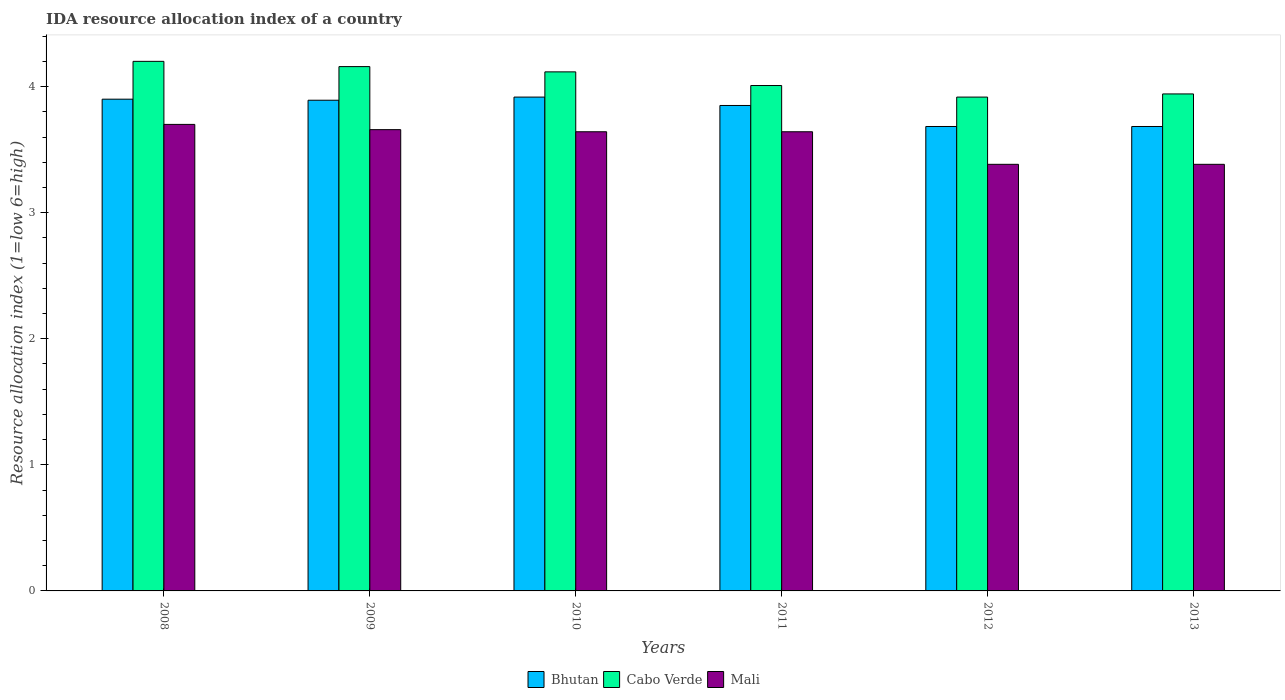How many different coloured bars are there?
Ensure brevity in your answer.  3. Are the number of bars per tick equal to the number of legend labels?
Offer a very short reply. Yes. Are the number of bars on each tick of the X-axis equal?
Your answer should be compact. Yes. How many bars are there on the 3rd tick from the left?
Provide a succinct answer. 3. How many bars are there on the 4th tick from the right?
Your answer should be very brief. 3. What is the label of the 3rd group of bars from the left?
Your response must be concise. 2010. In how many cases, is the number of bars for a given year not equal to the number of legend labels?
Your answer should be compact. 0. What is the IDA resource allocation index in Mali in 2013?
Provide a short and direct response. 3.38. Across all years, what is the minimum IDA resource allocation index in Bhutan?
Your answer should be compact. 3.68. In which year was the IDA resource allocation index in Bhutan maximum?
Your response must be concise. 2010. In which year was the IDA resource allocation index in Cabo Verde minimum?
Make the answer very short. 2012. What is the total IDA resource allocation index in Bhutan in the graph?
Ensure brevity in your answer.  22.92. What is the difference between the IDA resource allocation index in Cabo Verde in 2009 and that in 2010?
Ensure brevity in your answer.  0.04. What is the difference between the IDA resource allocation index in Cabo Verde in 2010 and the IDA resource allocation index in Mali in 2009?
Your answer should be very brief. 0.46. What is the average IDA resource allocation index in Mali per year?
Your answer should be compact. 3.57. In the year 2012, what is the difference between the IDA resource allocation index in Mali and IDA resource allocation index in Cabo Verde?
Provide a succinct answer. -0.53. In how many years, is the IDA resource allocation index in Bhutan greater than 1.4?
Offer a terse response. 6. What is the ratio of the IDA resource allocation index in Mali in 2008 to that in 2011?
Keep it short and to the point. 1.02. Is the IDA resource allocation index in Cabo Verde in 2011 less than that in 2013?
Make the answer very short. No. Is the difference between the IDA resource allocation index in Mali in 2009 and 2010 greater than the difference between the IDA resource allocation index in Cabo Verde in 2009 and 2010?
Give a very brief answer. No. What is the difference between the highest and the second highest IDA resource allocation index in Mali?
Offer a terse response. 0.04. What is the difference between the highest and the lowest IDA resource allocation index in Mali?
Offer a terse response. 0.32. In how many years, is the IDA resource allocation index in Bhutan greater than the average IDA resource allocation index in Bhutan taken over all years?
Keep it short and to the point. 4. What does the 1st bar from the left in 2011 represents?
Provide a short and direct response. Bhutan. What does the 1st bar from the right in 2009 represents?
Make the answer very short. Mali. How many bars are there?
Your answer should be compact. 18. How many years are there in the graph?
Your answer should be very brief. 6. What is the difference between two consecutive major ticks on the Y-axis?
Your answer should be very brief. 1. Are the values on the major ticks of Y-axis written in scientific E-notation?
Your answer should be very brief. No. Does the graph contain grids?
Give a very brief answer. No. Where does the legend appear in the graph?
Provide a succinct answer. Bottom center. How are the legend labels stacked?
Offer a very short reply. Horizontal. What is the title of the graph?
Your response must be concise. IDA resource allocation index of a country. What is the label or title of the X-axis?
Ensure brevity in your answer.  Years. What is the label or title of the Y-axis?
Your response must be concise. Resource allocation index (1=low 6=high). What is the Resource allocation index (1=low 6=high) of Bhutan in 2009?
Offer a terse response. 3.89. What is the Resource allocation index (1=low 6=high) of Cabo Verde in 2009?
Offer a terse response. 4.16. What is the Resource allocation index (1=low 6=high) in Mali in 2009?
Provide a succinct answer. 3.66. What is the Resource allocation index (1=low 6=high) in Bhutan in 2010?
Offer a very short reply. 3.92. What is the Resource allocation index (1=low 6=high) of Cabo Verde in 2010?
Give a very brief answer. 4.12. What is the Resource allocation index (1=low 6=high) in Mali in 2010?
Offer a very short reply. 3.64. What is the Resource allocation index (1=low 6=high) in Bhutan in 2011?
Your response must be concise. 3.85. What is the Resource allocation index (1=low 6=high) of Cabo Verde in 2011?
Make the answer very short. 4.01. What is the Resource allocation index (1=low 6=high) of Mali in 2011?
Your response must be concise. 3.64. What is the Resource allocation index (1=low 6=high) in Bhutan in 2012?
Offer a terse response. 3.68. What is the Resource allocation index (1=low 6=high) of Cabo Verde in 2012?
Give a very brief answer. 3.92. What is the Resource allocation index (1=low 6=high) of Mali in 2012?
Your answer should be very brief. 3.38. What is the Resource allocation index (1=low 6=high) of Bhutan in 2013?
Your response must be concise. 3.68. What is the Resource allocation index (1=low 6=high) of Cabo Verde in 2013?
Keep it short and to the point. 3.94. What is the Resource allocation index (1=low 6=high) of Mali in 2013?
Provide a short and direct response. 3.38. Across all years, what is the maximum Resource allocation index (1=low 6=high) in Bhutan?
Offer a terse response. 3.92. Across all years, what is the maximum Resource allocation index (1=low 6=high) in Mali?
Provide a succinct answer. 3.7. Across all years, what is the minimum Resource allocation index (1=low 6=high) in Bhutan?
Offer a terse response. 3.68. Across all years, what is the minimum Resource allocation index (1=low 6=high) of Cabo Verde?
Offer a terse response. 3.92. Across all years, what is the minimum Resource allocation index (1=low 6=high) in Mali?
Your answer should be very brief. 3.38. What is the total Resource allocation index (1=low 6=high) of Bhutan in the graph?
Keep it short and to the point. 22.93. What is the total Resource allocation index (1=low 6=high) in Cabo Verde in the graph?
Ensure brevity in your answer.  24.34. What is the total Resource allocation index (1=low 6=high) of Mali in the graph?
Your answer should be very brief. 21.41. What is the difference between the Resource allocation index (1=low 6=high) of Bhutan in 2008 and that in 2009?
Give a very brief answer. 0.01. What is the difference between the Resource allocation index (1=low 6=high) in Cabo Verde in 2008 and that in 2009?
Your answer should be very brief. 0.04. What is the difference between the Resource allocation index (1=low 6=high) in Mali in 2008 and that in 2009?
Provide a short and direct response. 0.04. What is the difference between the Resource allocation index (1=low 6=high) of Bhutan in 2008 and that in 2010?
Make the answer very short. -0.02. What is the difference between the Resource allocation index (1=low 6=high) of Cabo Verde in 2008 and that in 2010?
Provide a succinct answer. 0.08. What is the difference between the Resource allocation index (1=low 6=high) in Mali in 2008 and that in 2010?
Your response must be concise. 0.06. What is the difference between the Resource allocation index (1=low 6=high) in Cabo Verde in 2008 and that in 2011?
Give a very brief answer. 0.19. What is the difference between the Resource allocation index (1=low 6=high) of Mali in 2008 and that in 2011?
Provide a short and direct response. 0.06. What is the difference between the Resource allocation index (1=low 6=high) in Bhutan in 2008 and that in 2012?
Keep it short and to the point. 0.22. What is the difference between the Resource allocation index (1=low 6=high) in Cabo Verde in 2008 and that in 2012?
Offer a terse response. 0.28. What is the difference between the Resource allocation index (1=low 6=high) of Mali in 2008 and that in 2012?
Your answer should be very brief. 0.32. What is the difference between the Resource allocation index (1=low 6=high) in Bhutan in 2008 and that in 2013?
Provide a short and direct response. 0.22. What is the difference between the Resource allocation index (1=low 6=high) in Cabo Verde in 2008 and that in 2013?
Make the answer very short. 0.26. What is the difference between the Resource allocation index (1=low 6=high) in Mali in 2008 and that in 2013?
Provide a succinct answer. 0.32. What is the difference between the Resource allocation index (1=low 6=high) of Bhutan in 2009 and that in 2010?
Make the answer very short. -0.03. What is the difference between the Resource allocation index (1=low 6=high) in Cabo Verde in 2009 and that in 2010?
Offer a very short reply. 0.04. What is the difference between the Resource allocation index (1=low 6=high) in Mali in 2009 and that in 2010?
Keep it short and to the point. 0.02. What is the difference between the Resource allocation index (1=low 6=high) in Bhutan in 2009 and that in 2011?
Offer a terse response. 0.04. What is the difference between the Resource allocation index (1=low 6=high) in Cabo Verde in 2009 and that in 2011?
Provide a succinct answer. 0.15. What is the difference between the Resource allocation index (1=low 6=high) of Mali in 2009 and that in 2011?
Your answer should be very brief. 0.02. What is the difference between the Resource allocation index (1=low 6=high) in Bhutan in 2009 and that in 2012?
Offer a very short reply. 0.21. What is the difference between the Resource allocation index (1=low 6=high) of Cabo Verde in 2009 and that in 2012?
Provide a succinct answer. 0.24. What is the difference between the Resource allocation index (1=low 6=high) of Mali in 2009 and that in 2012?
Make the answer very short. 0.28. What is the difference between the Resource allocation index (1=low 6=high) of Bhutan in 2009 and that in 2013?
Give a very brief answer. 0.21. What is the difference between the Resource allocation index (1=low 6=high) of Cabo Verde in 2009 and that in 2013?
Provide a succinct answer. 0.22. What is the difference between the Resource allocation index (1=low 6=high) of Mali in 2009 and that in 2013?
Your answer should be compact. 0.28. What is the difference between the Resource allocation index (1=low 6=high) of Bhutan in 2010 and that in 2011?
Keep it short and to the point. 0.07. What is the difference between the Resource allocation index (1=low 6=high) of Cabo Verde in 2010 and that in 2011?
Offer a very short reply. 0.11. What is the difference between the Resource allocation index (1=low 6=high) in Mali in 2010 and that in 2011?
Your answer should be very brief. 0. What is the difference between the Resource allocation index (1=low 6=high) in Bhutan in 2010 and that in 2012?
Your answer should be very brief. 0.23. What is the difference between the Resource allocation index (1=low 6=high) of Cabo Verde in 2010 and that in 2012?
Provide a short and direct response. 0.2. What is the difference between the Resource allocation index (1=low 6=high) of Mali in 2010 and that in 2012?
Provide a short and direct response. 0.26. What is the difference between the Resource allocation index (1=low 6=high) in Bhutan in 2010 and that in 2013?
Offer a terse response. 0.23. What is the difference between the Resource allocation index (1=low 6=high) in Cabo Verde in 2010 and that in 2013?
Offer a terse response. 0.17. What is the difference between the Resource allocation index (1=low 6=high) of Mali in 2010 and that in 2013?
Offer a very short reply. 0.26. What is the difference between the Resource allocation index (1=low 6=high) of Bhutan in 2011 and that in 2012?
Your answer should be very brief. 0.17. What is the difference between the Resource allocation index (1=low 6=high) of Cabo Verde in 2011 and that in 2012?
Provide a short and direct response. 0.09. What is the difference between the Resource allocation index (1=low 6=high) of Mali in 2011 and that in 2012?
Your answer should be very brief. 0.26. What is the difference between the Resource allocation index (1=low 6=high) in Cabo Verde in 2011 and that in 2013?
Your answer should be compact. 0.07. What is the difference between the Resource allocation index (1=low 6=high) of Mali in 2011 and that in 2013?
Offer a terse response. 0.26. What is the difference between the Resource allocation index (1=low 6=high) of Bhutan in 2012 and that in 2013?
Your response must be concise. 0. What is the difference between the Resource allocation index (1=low 6=high) in Cabo Verde in 2012 and that in 2013?
Provide a succinct answer. -0.03. What is the difference between the Resource allocation index (1=low 6=high) of Mali in 2012 and that in 2013?
Your answer should be compact. 0. What is the difference between the Resource allocation index (1=low 6=high) of Bhutan in 2008 and the Resource allocation index (1=low 6=high) of Cabo Verde in 2009?
Make the answer very short. -0.26. What is the difference between the Resource allocation index (1=low 6=high) in Bhutan in 2008 and the Resource allocation index (1=low 6=high) in Mali in 2009?
Keep it short and to the point. 0.24. What is the difference between the Resource allocation index (1=low 6=high) in Cabo Verde in 2008 and the Resource allocation index (1=low 6=high) in Mali in 2009?
Your answer should be very brief. 0.54. What is the difference between the Resource allocation index (1=low 6=high) in Bhutan in 2008 and the Resource allocation index (1=low 6=high) in Cabo Verde in 2010?
Your answer should be compact. -0.22. What is the difference between the Resource allocation index (1=low 6=high) of Bhutan in 2008 and the Resource allocation index (1=low 6=high) of Mali in 2010?
Ensure brevity in your answer.  0.26. What is the difference between the Resource allocation index (1=low 6=high) of Cabo Verde in 2008 and the Resource allocation index (1=low 6=high) of Mali in 2010?
Provide a short and direct response. 0.56. What is the difference between the Resource allocation index (1=low 6=high) of Bhutan in 2008 and the Resource allocation index (1=low 6=high) of Cabo Verde in 2011?
Your answer should be very brief. -0.11. What is the difference between the Resource allocation index (1=low 6=high) of Bhutan in 2008 and the Resource allocation index (1=low 6=high) of Mali in 2011?
Ensure brevity in your answer.  0.26. What is the difference between the Resource allocation index (1=low 6=high) in Cabo Verde in 2008 and the Resource allocation index (1=low 6=high) in Mali in 2011?
Provide a short and direct response. 0.56. What is the difference between the Resource allocation index (1=low 6=high) in Bhutan in 2008 and the Resource allocation index (1=low 6=high) in Cabo Verde in 2012?
Keep it short and to the point. -0.02. What is the difference between the Resource allocation index (1=low 6=high) of Bhutan in 2008 and the Resource allocation index (1=low 6=high) of Mali in 2012?
Ensure brevity in your answer.  0.52. What is the difference between the Resource allocation index (1=low 6=high) in Cabo Verde in 2008 and the Resource allocation index (1=low 6=high) in Mali in 2012?
Give a very brief answer. 0.82. What is the difference between the Resource allocation index (1=low 6=high) of Bhutan in 2008 and the Resource allocation index (1=low 6=high) of Cabo Verde in 2013?
Make the answer very short. -0.04. What is the difference between the Resource allocation index (1=low 6=high) of Bhutan in 2008 and the Resource allocation index (1=low 6=high) of Mali in 2013?
Give a very brief answer. 0.52. What is the difference between the Resource allocation index (1=low 6=high) in Cabo Verde in 2008 and the Resource allocation index (1=low 6=high) in Mali in 2013?
Provide a succinct answer. 0.82. What is the difference between the Resource allocation index (1=low 6=high) in Bhutan in 2009 and the Resource allocation index (1=low 6=high) in Cabo Verde in 2010?
Make the answer very short. -0.23. What is the difference between the Resource allocation index (1=low 6=high) of Bhutan in 2009 and the Resource allocation index (1=low 6=high) of Mali in 2010?
Give a very brief answer. 0.25. What is the difference between the Resource allocation index (1=low 6=high) in Cabo Verde in 2009 and the Resource allocation index (1=low 6=high) in Mali in 2010?
Ensure brevity in your answer.  0.52. What is the difference between the Resource allocation index (1=low 6=high) in Bhutan in 2009 and the Resource allocation index (1=low 6=high) in Cabo Verde in 2011?
Your answer should be compact. -0.12. What is the difference between the Resource allocation index (1=low 6=high) of Bhutan in 2009 and the Resource allocation index (1=low 6=high) of Mali in 2011?
Provide a short and direct response. 0.25. What is the difference between the Resource allocation index (1=low 6=high) in Cabo Verde in 2009 and the Resource allocation index (1=low 6=high) in Mali in 2011?
Make the answer very short. 0.52. What is the difference between the Resource allocation index (1=low 6=high) in Bhutan in 2009 and the Resource allocation index (1=low 6=high) in Cabo Verde in 2012?
Ensure brevity in your answer.  -0.03. What is the difference between the Resource allocation index (1=low 6=high) in Bhutan in 2009 and the Resource allocation index (1=low 6=high) in Mali in 2012?
Keep it short and to the point. 0.51. What is the difference between the Resource allocation index (1=low 6=high) of Cabo Verde in 2009 and the Resource allocation index (1=low 6=high) of Mali in 2012?
Your answer should be very brief. 0.78. What is the difference between the Resource allocation index (1=low 6=high) of Bhutan in 2009 and the Resource allocation index (1=low 6=high) of Mali in 2013?
Your answer should be compact. 0.51. What is the difference between the Resource allocation index (1=low 6=high) of Cabo Verde in 2009 and the Resource allocation index (1=low 6=high) of Mali in 2013?
Make the answer very short. 0.78. What is the difference between the Resource allocation index (1=low 6=high) of Bhutan in 2010 and the Resource allocation index (1=low 6=high) of Cabo Verde in 2011?
Make the answer very short. -0.09. What is the difference between the Resource allocation index (1=low 6=high) in Bhutan in 2010 and the Resource allocation index (1=low 6=high) in Mali in 2011?
Your response must be concise. 0.28. What is the difference between the Resource allocation index (1=low 6=high) of Cabo Verde in 2010 and the Resource allocation index (1=low 6=high) of Mali in 2011?
Make the answer very short. 0.47. What is the difference between the Resource allocation index (1=low 6=high) in Bhutan in 2010 and the Resource allocation index (1=low 6=high) in Mali in 2012?
Provide a succinct answer. 0.53. What is the difference between the Resource allocation index (1=low 6=high) of Cabo Verde in 2010 and the Resource allocation index (1=low 6=high) of Mali in 2012?
Make the answer very short. 0.73. What is the difference between the Resource allocation index (1=low 6=high) in Bhutan in 2010 and the Resource allocation index (1=low 6=high) in Cabo Verde in 2013?
Give a very brief answer. -0.03. What is the difference between the Resource allocation index (1=low 6=high) of Bhutan in 2010 and the Resource allocation index (1=low 6=high) of Mali in 2013?
Ensure brevity in your answer.  0.53. What is the difference between the Resource allocation index (1=low 6=high) of Cabo Verde in 2010 and the Resource allocation index (1=low 6=high) of Mali in 2013?
Provide a short and direct response. 0.73. What is the difference between the Resource allocation index (1=low 6=high) in Bhutan in 2011 and the Resource allocation index (1=low 6=high) in Cabo Verde in 2012?
Give a very brief answer. -0.07. What is the difference between the Resource allocation index (1=low 6=high) of Bhutan in 2011 and the Resource allocation index (1=low 6=high) of Mali in 2012?
Offer a terse response. 0.47. What is the difference between the Resource allocation index (1=low 6=high) of Cabo Verde in 2011 and the Resource allocation index (1=low 6=high) of Mali in 2012?
Ensure brevity in your answer.  0.62. What is the difference between the Resource allocation index (1=low 6=high) of Bhutan in 2011 and the Resource allocation index (1=low 6=high) of Cabo Verde in 2013?
Your answer should be compact. -0.09. What is the difference between the Resource allocation index (1=low 6=high) of Bhutan in 2011 and the Resource allocation index (1=low 6=high) of Mali in 2013?
Make the answer very short. 0.47. What is the difference between the Resource allocation index (1=low 6=high) of Cabo Verde in 2011 and the Resource allocation index (1=low 6=high) of Mali in 2013?
Provide a succinct answer. 0.62. What is the difference between the Resource allocation index (1=low 6=high) of Bhutan in 2012 and the Resource allocation index (1=low 6=high) of Cabo Verde in 2013?
Your answer should be compact. -0.26. What is the difference between the Resource allocation index (1=low 6=high) of Bhutan in 2012 and the Resource allocation index (1=low 6=high) of Mali in 2013?
Make the answer very short. 0.3. What is the difference between the Resource allocation index (1=low 6=high) of Cabo Verde in 2012 and the Resource allocation index (1=low 6=high) of Mali in 2013?
Give a very brief answer. 0.53. What is the average Resource allocation index (1=low 6=high) in Bhutan per year?
Your response must be concise. 3.82. What is the average Resource allocation index (1=low 6=high) in Cabo Verde per year?
Offer a terse response. 4.06. What is the average Resource allocation index (1=low 6=high) in Mali per year?
Make the answer very short. 3.57. In the year 2008, what is the difference between the Resource allocation index (1=low 6=high) in Bhutan and Resource allocation index (1=low 6=high) in Cabo Verde?
Give a very brief answer. -0.3. In the year 2009, what is the difference between the Resource allocation index (1=low 6=high) in Bhutan and Resource allocation index (1=low 6=high) in Cabo Verde?
Provide a succinct answer. -0.27. In the year 2009, what is the difference between the Resource allocation index (1=low 6=high) in Bhutan and Resource allocation index (1=low 6=high) in Mali?
Your response must be concise. 0.23. In the year 2009, what is the difference between the Resource allocation index (1=low 6=high) of Cabo Verde and Resource allocation index (1=low 6=high) of Mali?
Ensure brevity in your answer.  0.5. In the year 2010, what is the difference between the Resource allocation index (1=low 6=high) of Bhutan and Resource allocation index (1=low 6=high) of Mali?
Your answer should be very brief. 0.28. In the year 2010, what is the difference between the Resource allocation index (1=low 6=high) of Cabo Verde and Resource allocation index (1=low 6=high) of Mali?
Offer a terse response. 0.47. In the year 2011, what is the difference between the Resource allocation index (1=low 6=high) in Bhutan and Resource allocation index (1=low 6=high) in Cabo Verde?
Your answer should be compact. -0.16. In the year 2011, what is the difference between the Resource allocation index (1=low 6=high) of Bhutan and Resource allocation index (1=low 6=high) of Mali?
Provide a succinct answer. 0.21. In the year 2011, what is the difference between the Resource allocation index (1=low 6=high) of Cabo Verde and Resource allocation index (1=low 6=high) of Mali?
Your answer should be compact. 0.37. In the year 2012, what is the difference between the Resource allocation index (1=low 6=high) in Bhutan and Resource allocation index (1=low 6=high) in Cabo Verde?
Give a very brief answer. -0.23. In the year 2012, what is the difference between the Resource allocation index (1=low 6=high) of Cabo Verde and Resource allocation index (1=low 6=high) of Mali?
Provide a short and direct response. 0.53. In the year 2013, what is the difference between the Resource allocation index (1=low 6=high) of Bhutan and Resource allocation index (1=low 6=high) of Cabo Verde?
Provide a succinct answer. -0.26. In the year 2013, what is the difference between the Resource allocation index (1=low 6=high) in Bhutan and Resource allocation index (1=low 6=high) in Mali?
Offer a terse response. 0.3. In the year 2013, what is the difference between the Resource allocation index (1=low 6=high) of Cabo Verde and Resource allocation index (1=low 6=high) of Mali?
Provide a succinct answer. 0.56. What is the ratio of the Resource allocation index (1=low 6=high) of Bhutan in 2008 to that in 2009?
Ensure brevity in your answer.  1. What is the ratio of the Resource allocation index (1=low 6=high) of Cabo Verde in 2008 to that in 2009?
Your response must be concise. 1.01. What is the ratio of the Resource allocation index (1=low 6=high) of Mali in 2008 to that in 2009?
Your response must be concise. 1.01. What is the ratio of the Resource allocation index (1=low 6=high) in Bhutan in 2008 to that in 2010?
Ensure brevity in your answer.  1. What is the ratio of the Resource allocation index (1=low 6=high) of Cabo Verde in 2008 to that in 2010?
Provide a succinct answer. 1.02. What is the ratio of the Resource allocation index (1=low 6=high) of Bhutan in 2008 to that in 2011?
Your response must be concise. 1.01. What is the ratio of the Resource allocation index (1=low 6=high) in Cabo Verde in 2008 to that in 2011?
Ensure brevity in your answer.  1.05. What is the ratio of the Resource allocation index (1=low 6=high) of Bhutan in 2008 to that in 2012?
Give a very brief answer. 1.06. What is the ratio of the Resource allocation index (1=low 6=high) of Cabo Verde in 2008 to that in 2012?
Provide a short and direct response. 1.07. What is the ratio of the Resource allocation index (1=low 6=high) of Mali in 2008 to that in 2012?
Provide a short and direct response. 1.09. What is the ratio of the Resource allocation index (1=low 6=high) of Bhutan in 2008 to that in 2013?
Make the answer very short. 1.06. What is the ratio of the Resource allocation index (1=low 6=high) in Cabo Verde in 2008 to that in 2013?
Your answer should be compact. 1.07. What is the ratio of the Resource allocation index (1=low 6=high) of Mali in 2008 to that in 2013?
Ensure brevity in your answer.  1.09. What is the ratio of the Resource allocation index (1=low 6=high) of Bhutan in 2009 to that in 2010?
Your response must be concise. 0.99. What is the ratio of the Resource allocation index (1=low 6=high) of Cabo Verde in 2009 to that in 2010?
Your answer should be very brief. 1.01. What is the ratio of the Resource allocation index (1=low 6=high) of Bhutan in 2009 to that in 2011?
Keep it short and to the point. 1.01. What is the ratio of the Resource allocation index (1=low 6=high) of Cabo Verde in 2009 to that in 2011?
Offer a terse response. 1.04. What is the ratio of the Resource allocation index (1=low 6=high) of Mali in 2009 to that in 2011?
Your answer should be very brief. 1. What is the ratio of the Resource allocation index (1=low 6=high) of Bhutan in 2009 to that in 2012?
Offer a terse response. 1.06. What is the ratio of the Resource allocation index (1=low 6=high) in Cabo Verde in 2009 to that in 2012?
Your answer should be compact. 1.06. What is the ratio of the Resource allocation index (1=low 6=high) in Mali in 2009 to that in 2012?
Ensure brevity in your answer.  1.08. What is the ratio of the Resource allocation index (1=low 6=high) of Bhutan in 2009 to that in 2013?
Offer a terse response. 1.06. What is the ratio of the Resource allocation index (1=low 6=high) of Cabo Verde in 2009 to that in 2013?
Give a very brief answer. 1.05. What is the ratio of the Resource allocation index (1=low 6=high) of Mali in 2009 to that in 2013?
Keep it short and to the point. 1.08. What is the ratio of the Resource allocation index (1=low 6=high) of Bhutan in 2010 to that in 2011?
Your response must be concise. 1.02. What is the ratio of the Resource allocation index (1=low 6=high) in Bhutan in 2010 to that in 2012?
Provide a succinct answer. 1.06. What is the ratio of the Resource allocation index (1=low 6=high) in Cabo Verde in 2010 to that in 2012?
Keep it short and to the point. 1.05. What is the ratio of the Resource allocation index (1=low 6=high) in Mali in 2010 to that in 2012?
Provide a short and direct response. 1.08. What is the ratio of the Resource allocation index (1=low 6=high) of Bhutan in 2010 to that in 2013?
Offer a very short reply. 1.06. What is the ratio of the Resource allocation index (1=low 6=high) of Cabo Verde in 2010 to that in 2013?
Provide a short and direct response. 1.04. What is the ratio of the Resource allocation index (1=low 6=high) in Mali in 2010 to that in 2013?
Give a very brief answer. 1.08. What is the ratio of the Resource allocation index (1=low 6=high) of Bhutan in 2011 to that in 2012?
Your response must be concise. 1.05. What is the ratio of the Resource allocation index (1=low 6=high) in Cabo Verde in 2011 to that in 2012?
Offer a terse response. 1.02. What is the ratio of the Resource allocation index (1=low 6=high) in Mali in 2011 to that in 2012?
Provide a succinct answer. 1.08. What is the ratio of the Resource allocation index (1=low 6=high) in Bhutan in 2011 to that in 2013?
Your response must be concise. 1.05. What is the ratio of the Resource allocation index (1=low 6=high) of Cabo Verde in 2011 to that in 2013?
Provide a short and direct response. 1.02. What is the ratio of the Resource allocation index (1=low 6=high) in Mali in 2011 to that in 2013?
Provide a short and direct response. 1.08. What is the ratio of the Resource allocation index (1=low 6=high) of Bhutan in 2012 to that in 2013?
Make the answer very short. 1. What is the ratio of the Resource allocation index (1=low 6=high) in Cabo Verde in 2012 to that in 2013?
Offer a very short reply. 0.99. What is the ratio of the Resource allocation index (1=low 6=high) of Mali in 2012 to that in 2013?
Offer a terse response. 1. What is the difference between the highest and the second highest Resource allocation index (1=low 6=high) in Bhutan?
Ensure brevity in your answer.  0.02. What is the difference between the highest and the second highest Resource allocation index (1=low 6=high) in Cabo Verde?
Provide a short and direct response. 0.04. What is the difference between the highest and the second highest Resource allocation index (1=low 6=high) of Mali?
Ensure brevity in your answer.  0.04. What is the difference between the highest and the lowest Resource allocation index (1=low 6=high) of Bhutan?
Your response must be concise. 0.23. What is the difference between the highest and the lowest Resource allocation index (1=low 6=high) of Cabo Verde?
Your answer should be compact. 0.28. What is the difference between the highest and the lowest Resource allocation index (1=low 6=high) in Mali?
Make the answer very short. 0.32. 